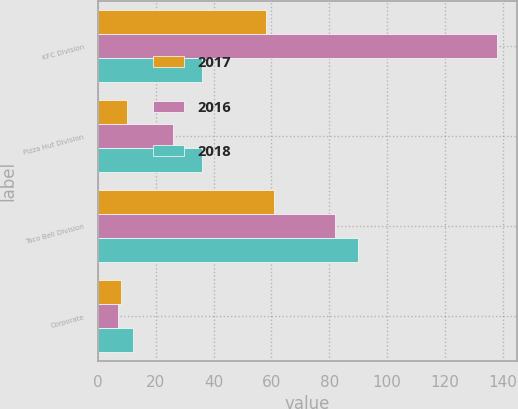Convert chart to OTSL. <chart><loc_0><loc_0><loc_500><loc_500><stacked_bar_chart><ecel><fcel>KFC Division<fcel>Pizza Hut Division<fcel>Taco Bell Division<fcel>Corporate<nl><fcel>2017<fcel>58<fcel>10<fcel>61<fcel>8<nl><fcel>2016<fcel>138<fcel>26<fcel>82<fcel>7<nl><fcel>2018<fcel>36<fcel>36<fcel>90<fcel>12<nl></chart> 